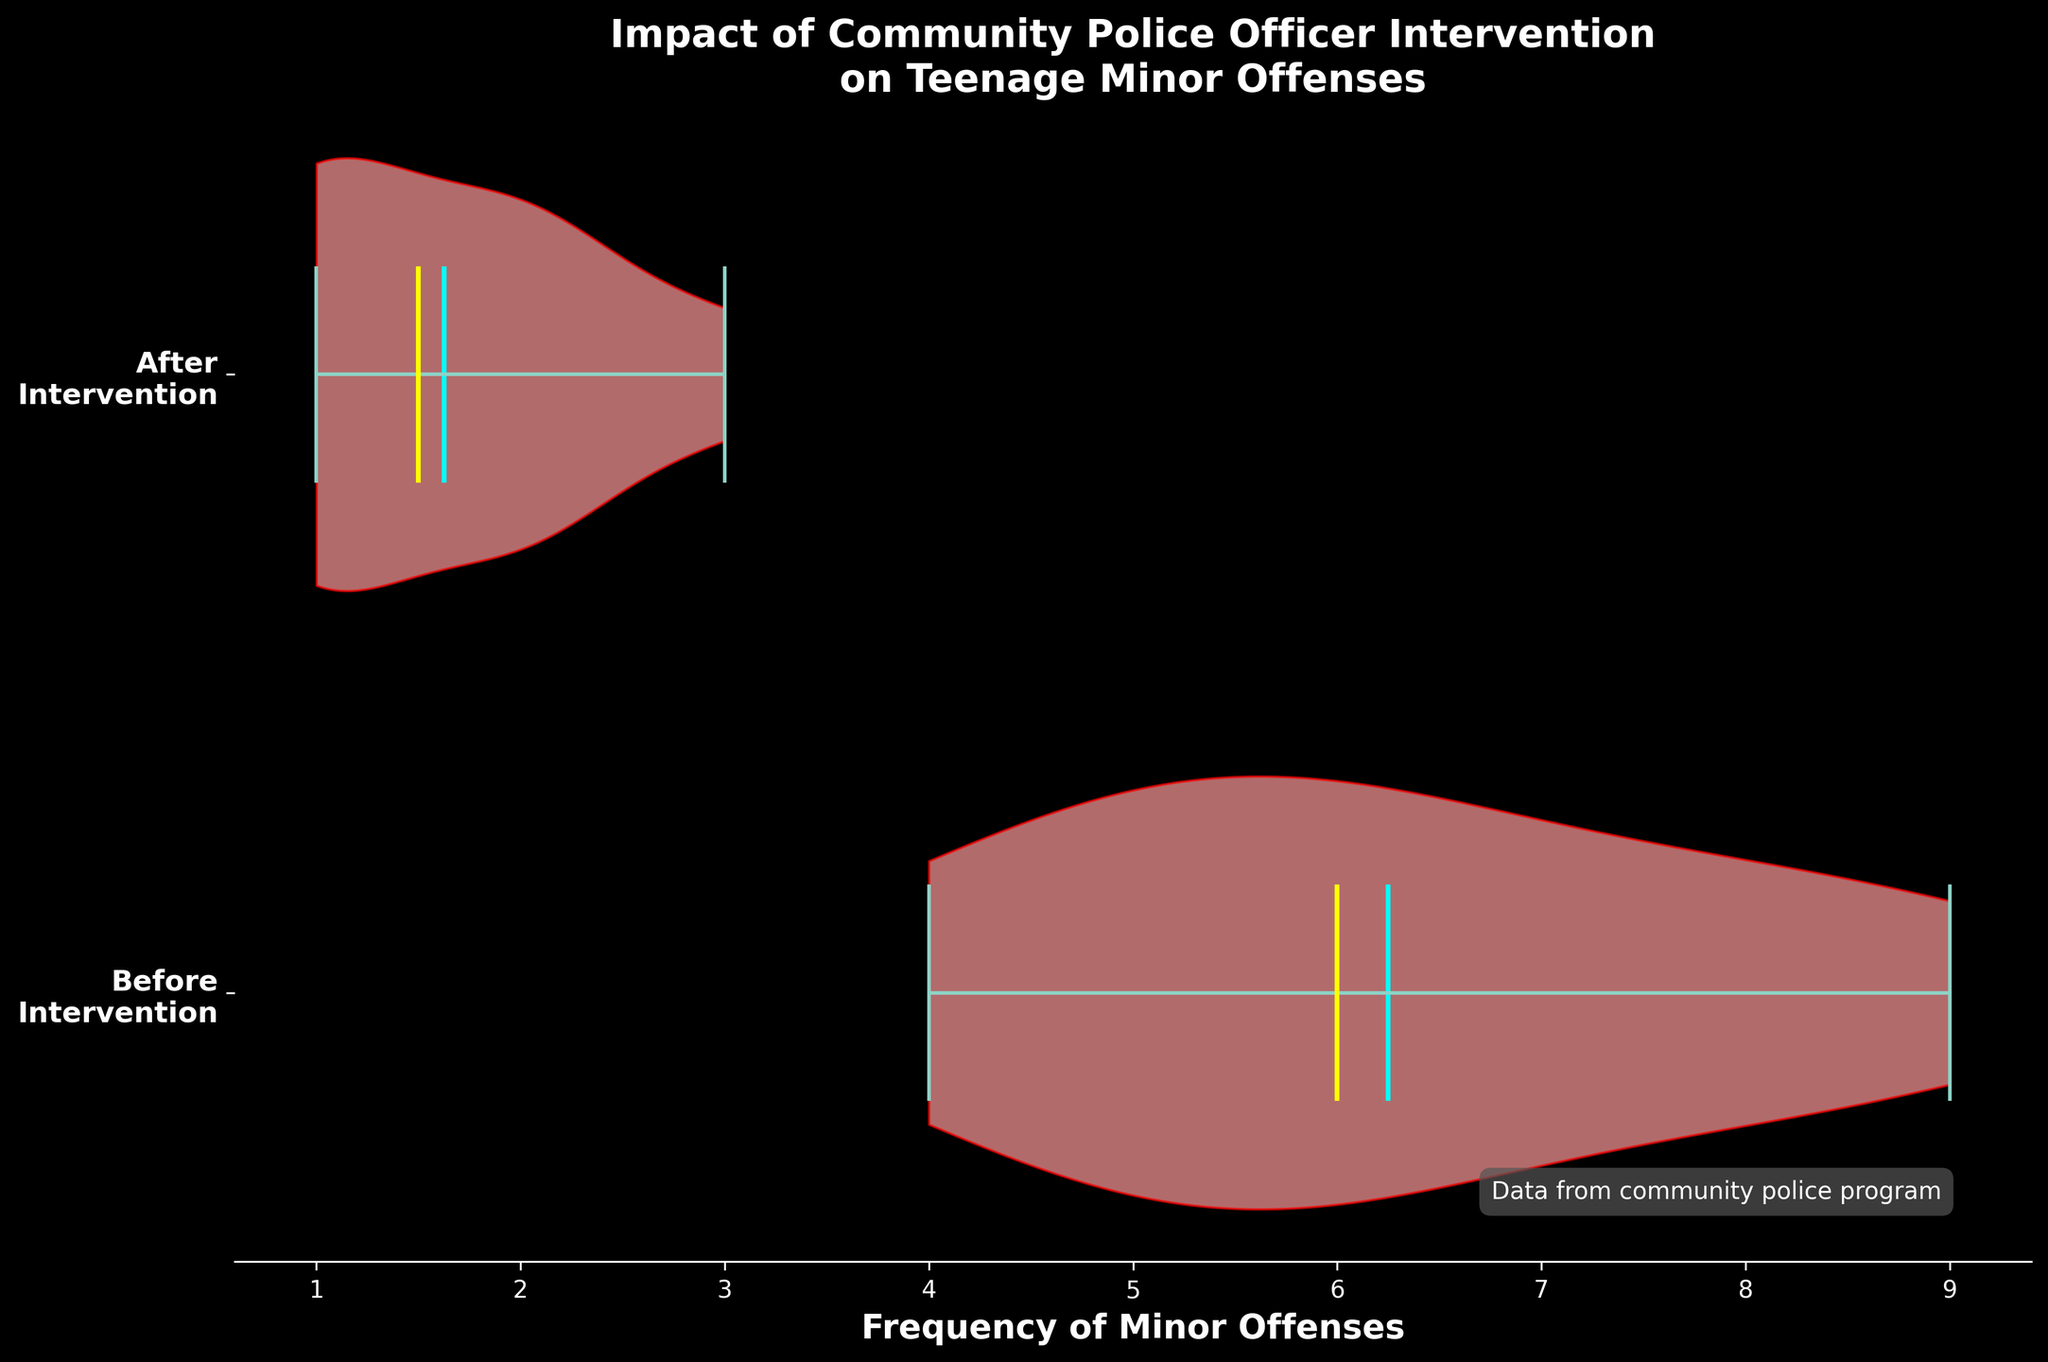what are the two groups being compared in the chart? The chart compares the frequency of minor offenses committed by teenagers before and after intervention programs. This can be determined from the y-axis labels that read "Before Intervention" and "After Intervention."
Answer: Before Intervention, After Intervention What is the median frequency of minor offenses before the intervention? The median value of a dataset is the middle value when the data points are arranged in ascending order. The yellow line inside the violin plot for the "Before Intervention" group indicates this value.
Answer: 6 What can be inferred about the effectiveness of the community police officer intervention program? The violin plot shows that the spread of frequency of minor offenses significantly reduces from "Before Intervention" to "After Intervention." This is visible through the width and placement of the violins, suggesting the program is effective in reducing minor offenses.
Answer: The program is effective What is the mean frequency of minor offenses after the intervention? The mean value is indicated by the cyan color line inside the violin plot for the "After Intervention" group.
Answer: 1.625 Compare the variability in the frequency of minor offenses in the "Before Intervention" and "After Intervention" groups. The width of the violin plots represents variability in data. The "Before Intervention" plot is wider and covers a larger range, indicating higher variability compared to the narrower "After Intervention" plot.
Answer: Higher before intervention, lower after intervention What colors are used to indicate the means and medians in the chart? The cyan color line represents the mean values, and the yellow color line represents the median values in the violin plots.
Answer: Cyan for mean, yellow for median How many teenagers' data are represented in the chart? Each violins' frequency is based on the same set of teenagers, both before and after intervention. Listing each teenager from the data provided shows there are 7 teenagers.
Answer: 7 Which teenager shows the highest reduction in minor offenses after the intervention? By comparing the "Before" and "After" values for each individual, Emily Davis shows the highest reduction from 8 to 2, which is a reduction of 6 offenses.
Answer: Emily Davis, 6 offenses What do the dots along the violin plot edges represent? These dots are the individual data points representing the frequency of minor offenses for each teenager within the groups "Before" and "After" intervention.
Answer: Individual data points Based on the chart, which group shows a more concentrated distribution of minor offenses? The "After Intervention" group shows a more concentrated distribution, as indicated by the narrower and more focused shape of the violin plot.
Answer: After Intervention 